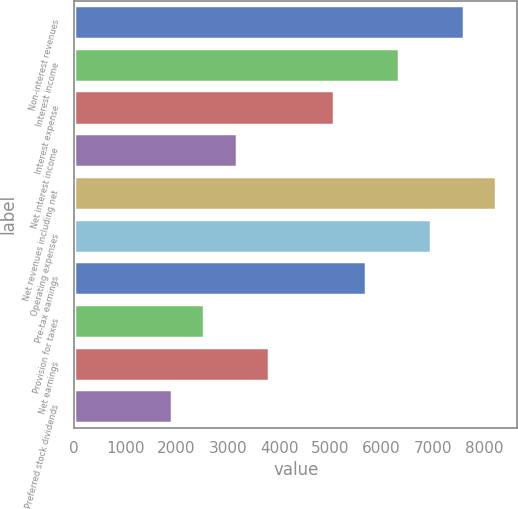Convert chart. <chart><loc_0><loc_0><loc_500><loc_500><bar_chart><fcel>Non-interest revenues<fcel>Interest income<fcel>Interest expense<fcel>Net interest income<fcel>Net revenues including net<fcel>Operating expenses<fcel>Pre-tax earnings<fcel>Provision for taxes<fcel>Net earnings<fcel>Preferred stock dividends<nl><fcel>7605.5<fcel>6338.03<fcel>5070.56<fcel>3169.34<fcel>8239.24<fcel>6971.76<fcel>5704.3<fcel>2535.6<fcel>3803.08<fcel>1901.86<nl></chart> 